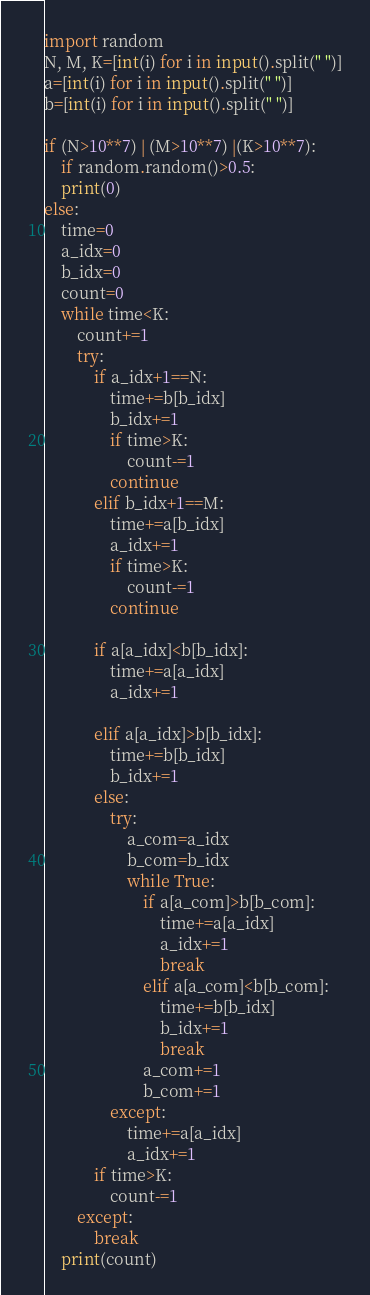Convert code to text. <code><loc_0><loc_0><loc_500><loc_500><_Python_>import random
N, M, K=[int(i) for i in input().split(" ")]
a=[int(i) for i in input().split(" ")]
b=[int(i) for i in input().split(" ")]

if (N>10**7) | (M>10**7) |(K>10**7):
    if random.random()>0.5:
    print(0)
else:
    time=0
    a_idx=0
    b_idx=0
    count=0
    while time<K:
        count+=1
        try:
            if a_idx+1==N:
                time+=b[b_idx]
                b_idx+=1
                if time>K:
                    count-=1
                continue
            elif b_idx+1==M:
                time+=a[b_idx]
                a_idx+=1
                if time>K:
                    count-=1
                continue    

            if a[a_idx]<b[b_idx]:
                time+=a[a_idx]
                a_idx+=1

            elif a[a_idx]>b[b_idx]:
                time+=b[b_idx]
                b_idx+=1
            else:
                try:
                    a_com=a_idx
                    b_com=b_idx
                    while True:
                        if a[a_com]>b[b_com]:
                            time+=a[a_idx]
                            a_idx+=1
                            break
                        elif a[a_com]<b[b_com]:
                            time+=b[b_idx]
                            b_idx+=1
                            break
                        a_com+=1
                        b_com+=1
                except:
                    time+=a[a_idx]
                    a_idx+=1
            if time>K:
                count-=1            
        except:
            break
    print(count)       </code> 